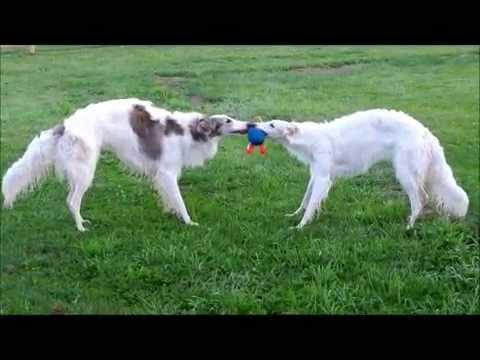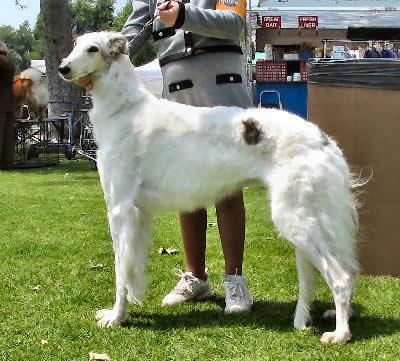The first image is the image on the left, the second image is the image on the right. For the images displayed, is the sentence "There is more than one dog in the image on the left." factually correct? Answer yes or no. Yes. 